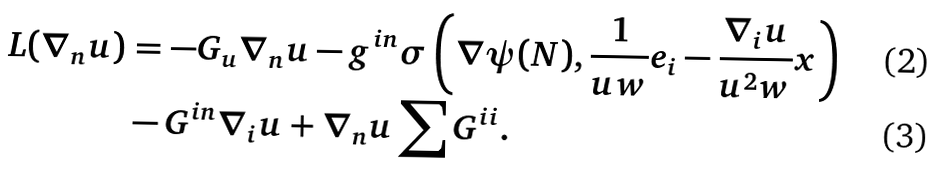Convert formula to latex. <formula><loc_0><loc_0><loc_500><loc_500>L ( \nabla _ { n } u ) & = - G _ { u } \nabla _ { n } u - g ^ { i n } \sigma \left ( \nabla \psi ( N ) , \frac { 1 } { u w } e _ { i } - \frac { \nabla _ { i } u } { u ^ { 2 } w } x \right ) \\ & - G ^ { i n } \nabla _ { i } u + \nabla _ { n } u \sum G ^ { i i } .</formula> 